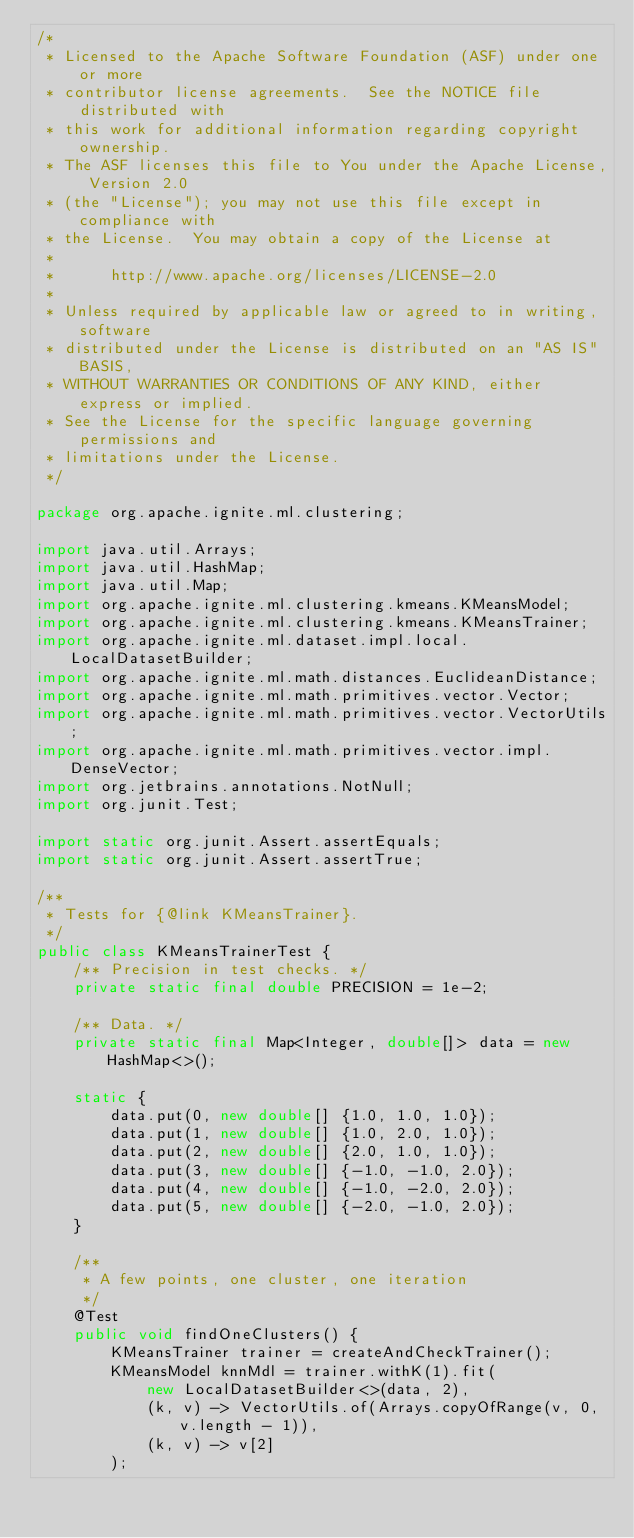Convert code to text. <code><loc_0><loc_0><loc_500><loc_500><_Java_>/*
 * Licensed to the Apache Software Foundation (ASF) under one or more
 * contributor license agreements.  See the NOTICE file distributed with
 * this work for additional information regarding copyright ownership.
 * The ASF licenses this file to You under the Apache License, Version 2.0
 * (the "License"); you may not use this file except in compliance with
 * the License.  You may obtain a copy of the License at
 *
 *      http://www.apache.org/licenses/LICENSE-2.0
 *
 * Unless required by applicable law or agreed to in writing, software
 * distributed under the License is distributed on an "AS IS" BASIS,
 * WITHOUT WARRANTIES OR CONDITIONS OF ANY KIND, either express or implied.
 * See the License for the specific language governing permissions and
 * limitations under the License.
 */

package org.apache.ignite.ml.clustering;

import java.util.Arrays;
import java.util.HashMap;
import java.util.Map;
import org.apache.ignite.ml.clustering.kmeans.KMeansModel;
import org.apache.ignite.ml.clustering.kmeans.KMeansTrainer;
import org.apache.ignite.ml.dataset.impl.local.LocalDatasetBuilder;
import org.apache.ignite.ml.math.distances.EuclideanDistance;
import org.apache.ignite.ml.math.primitives.vector.Vector;
import org.apache.ignite.ml.math.primitives.vector.VectorUtils;
import org.apache.ignite.ml.math.primitives.vector.impl.DenseVector;
import org.jetbrains.annotations.NotNull;
import org.junit.Test;

import static org.junit.Assert.assertEquals;
import static org.junit.Assert.assertTrue;

/**
 * Tests for {@link KMeansTrainer}.
 */
public class KMeansTrainerTest {
    /** Precision in test checks. */
    private static final double PRECISION = 1e-2;

    /** Data. */
    private static final Map<Integer, double[]> data = new HashMap<>();

    static {
        data.put(0, new double[] {1.0, 1.0, 1.0});
        data.put(1, new double[] {1.0, 2.0, 1.0});
        data.put(2, new double[] {2.0, 1.0, 1.0});
        data.put(3, new double[] {-1.0, -1.0, 2.0});
        data.put(4, new double[] {-1.0, -2.0, 2.0});
        data.put(5, new double[] {-2.0, -1.0, 2.0});
    }

    /**
     * A few points, one cluster, one iteration
     */
    @Test
    public void findOneClusters() {
        KMeansTrainer trainer = createAndCheckTrainer();
        KMeansModel knnMdl = trainer.withK(1).fit(
            new LocalDatasetBuilder<>(data, 2),
            (k, v) -> VectorUtils.of(Arrays.copyOfRange(v, 0, v.length - 1)),
            (k, v) -> v[2]
        );
</code> 